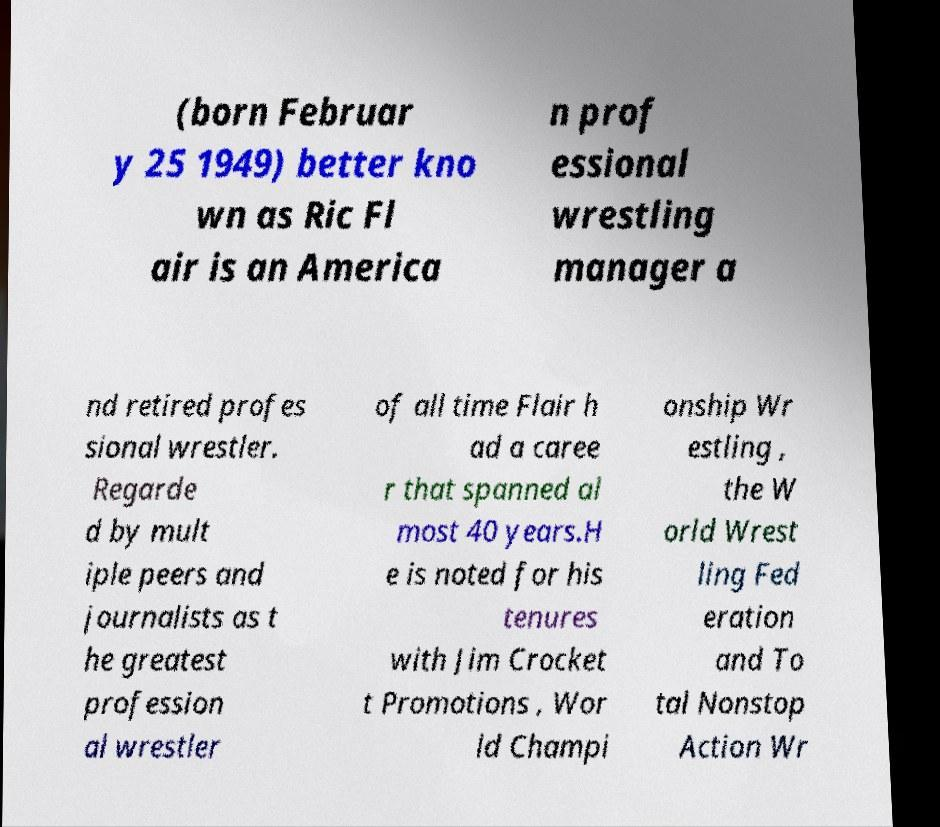Could you assist in decoding the text presented in this image and type it out clearly? (born Februar y 25 1949) better kno wn as Ric Fl air is an America n prof essional wrestling manager a nd retired profes sional wrestler. Regarde d by mult iple peers and journalists as t he greatest profession al wrestler of all time Flair h ad a caree r that spanned al most 40 years.H e is noted for his tenures with Jim Crocket t Promotions , Wor ld Champi onship Wr estling , the W orld Wrest ling Fed eration and To tal Nonstop Action Wr 